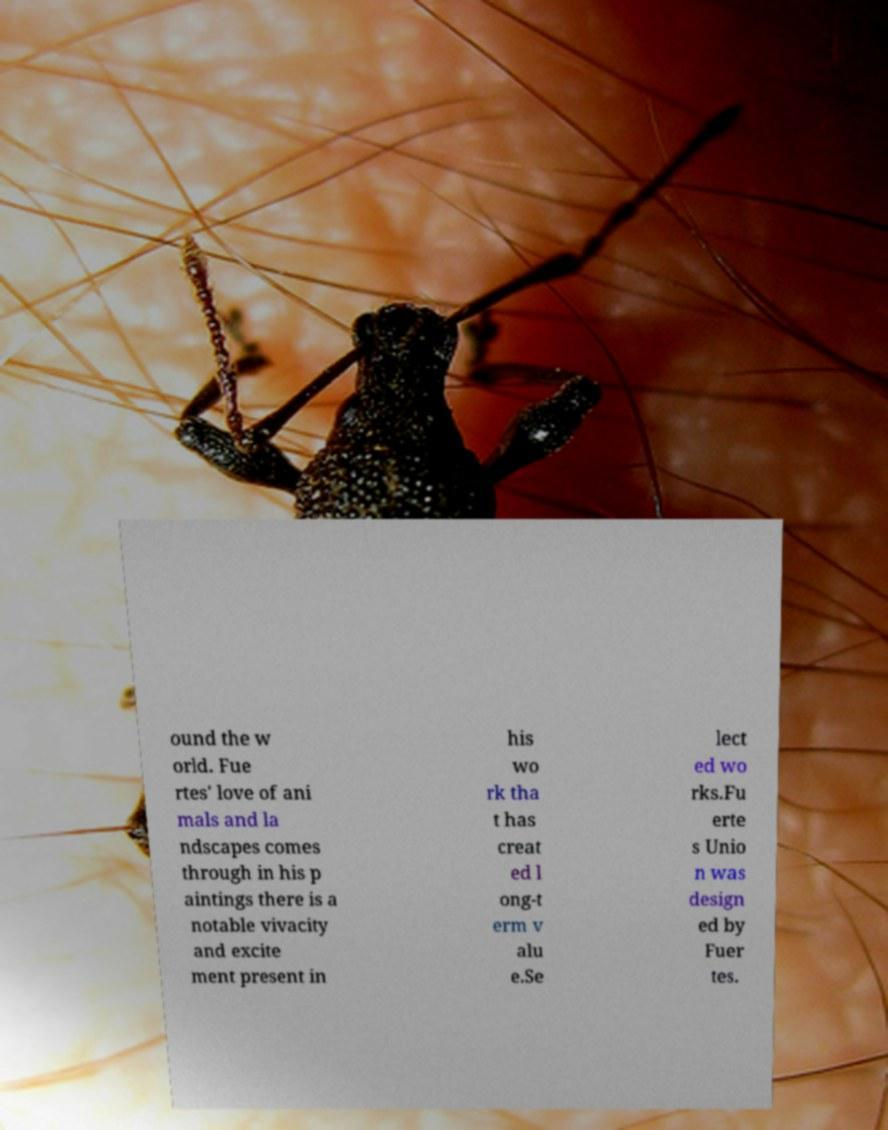There's text embedded in this image that I need extracted. Can you transcribe it verbatim? ound the w orld. Fue rtes' love of ani mals and la ndscapes comes through in his p aintings there is a notable vivacity and excite ment present in his wo rk tha t has creat ed l ong-t erm v alu e.Se lect ed wo rks.Fu erte s Unio n was design ed by Fuer tes. 